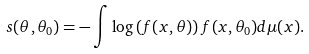Convert formula to latex. <formula><loc_0><loc_0><loc_500><loc_500>s ( \theta , \theta _ { 0 } ) = - \int \log \left ( f ( x , \theta ) \right ) f ( x , \theta _ { 0 } ) d \mu ( x ) .</formula> 